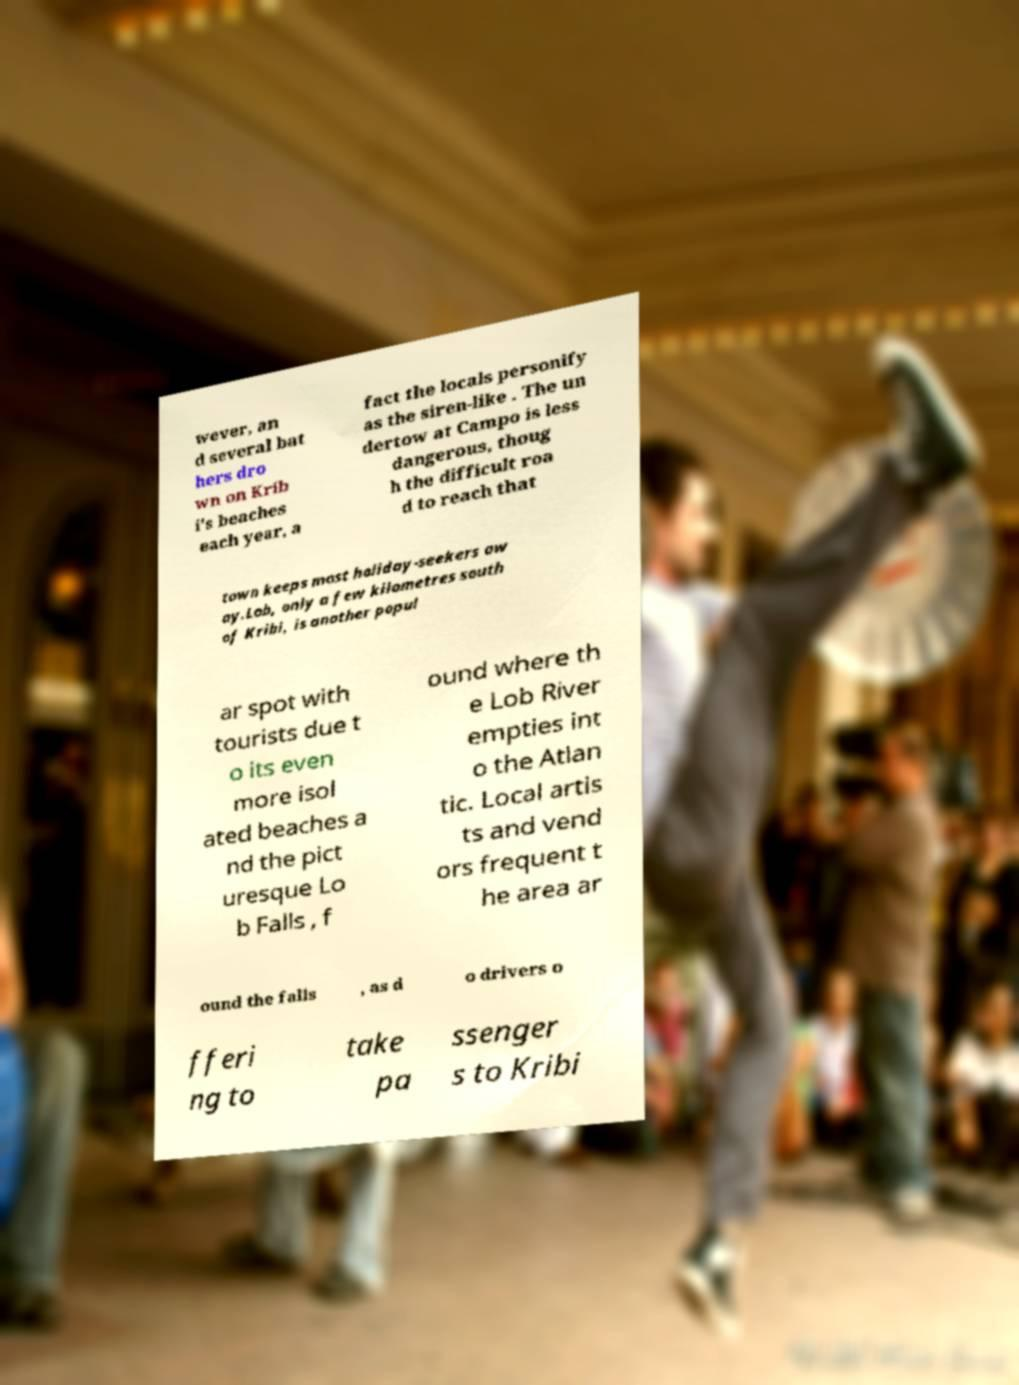Can you accurately transcribe the text from the provided image for me? wever, an d several bat hers dro wn on Krib i's beaches each year, a fact the locals personify as the siren-like . The un dertow at Campo is less dangerous, thoug h the difficult roa d to reach that town keeps most holiday-seekers aw ay.Lob, only a few kilometres south of Kribi, is another popul ar spot with tourists due t o its even more isol ated beaches a nd the pict uresque Lo b Falls , f ound where th e Lob River empties int o the Atlan tic. Local artis ts and vend ors frequent t he area ar ound the falls , as d o drivers o fferi ng to take pa ssenger s to Kribi 